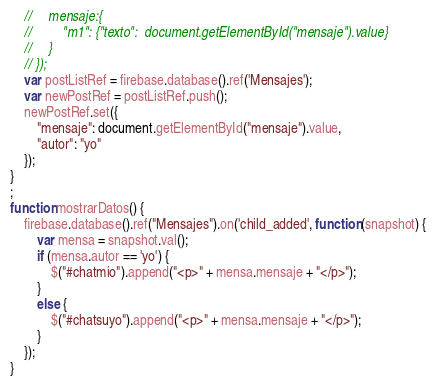Convert code to text. <code><loc_0><loc_0><loc_500><loc_500><_JavaScript_>    //     mensaje:{
    //         "m1": {"texto":  document.getElementById("mensaje").value}
    //     }
    // });
    var postListRef = firebase.database().ref('Mensajes');
    var newPostRef = postListRef.push();
    newPostRef.set({
        "mensaje": document.getElementById("mensaje").value,
        "autor": "yo"
    });
}
;
function mostrarDatos() {
    firebase.database().ref("Mensajes").on('child_added', function (snapshot) {
        var mensa = snapshot.val();
        if (mensa.autor == 'yo') {
            $("#chatmio").append("<p>" + mensa.mensaje + "</p>");
        }
        else {
            $("#chatsuyo").append("<p>" + mensa.mensaje + "</p>");
        }
    });
}
</code> 